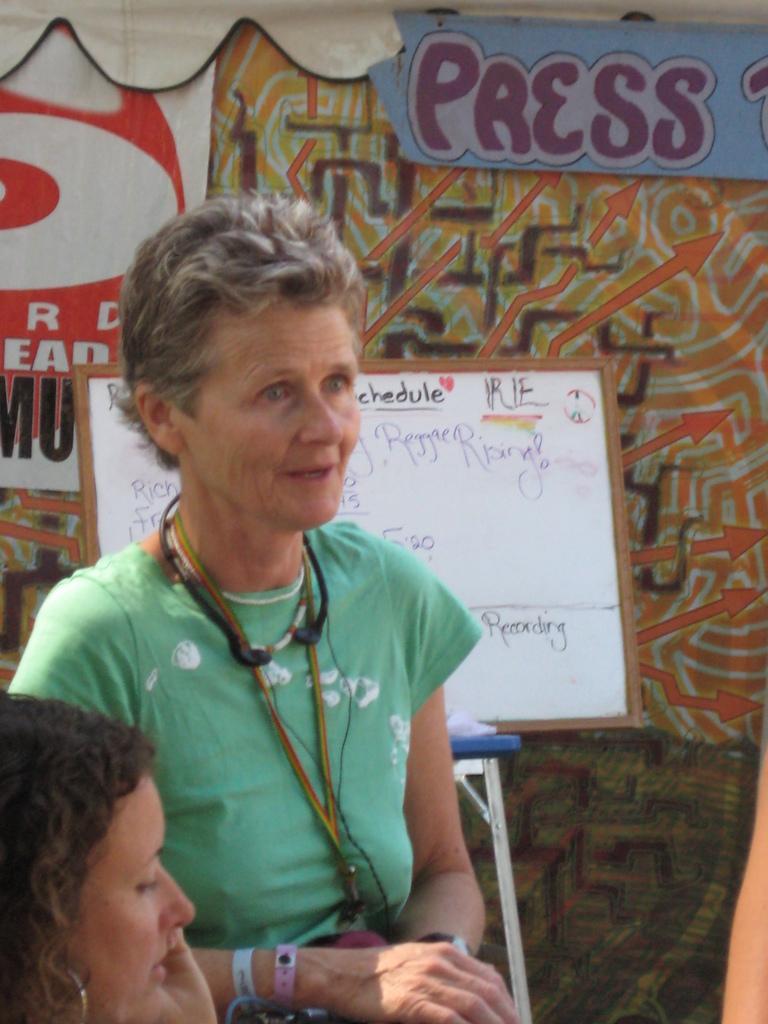Please provide a concise description of this image. On the left side of the image two ladies are there. In the center of the image board, stand are present. In the background of the image tent is there. 